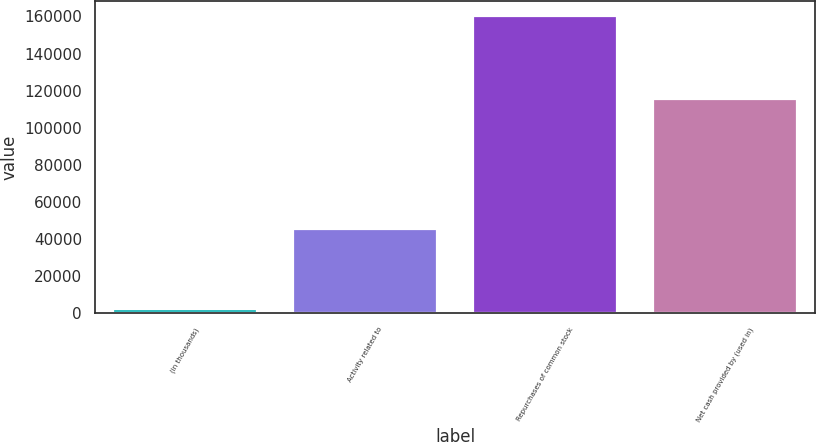Convert chart. <chart><loc_0><loc_0><loc_500><loc_500><bar_chart><fcel>(in thousands)<fcel>Activity related to<fcel>Repurchases of common stock<fcel>Net cash provided by (used in)<nl><fcel>2013<fcel>45176<fcel>160419<fcel>115243<nl></chart> 